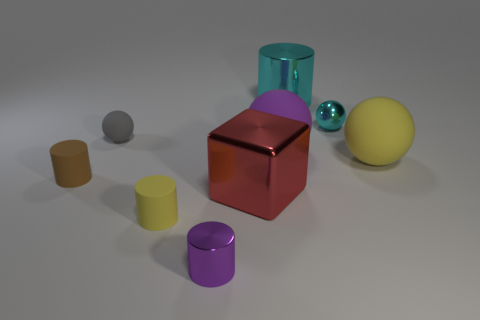Subtract 1 balls. How many balls are left? 3 Subtract all purple cylinders. Subtract all green blocks. How many cylinders are left? 3 Add 1 brown cylinders. How many objects exist? 10 Subtract all blocks. How many objects are left? 8 Subtract all matte things. Subtract all tiny brown cylinders. How many objects are left? 3 Add 4 big balls. How many big balls are left? 6 Add 3 tiny brown shiny objects. How many tiny brown shiny objects exist? 3 Subtract 0 brown balls. How many objects are left? 9 